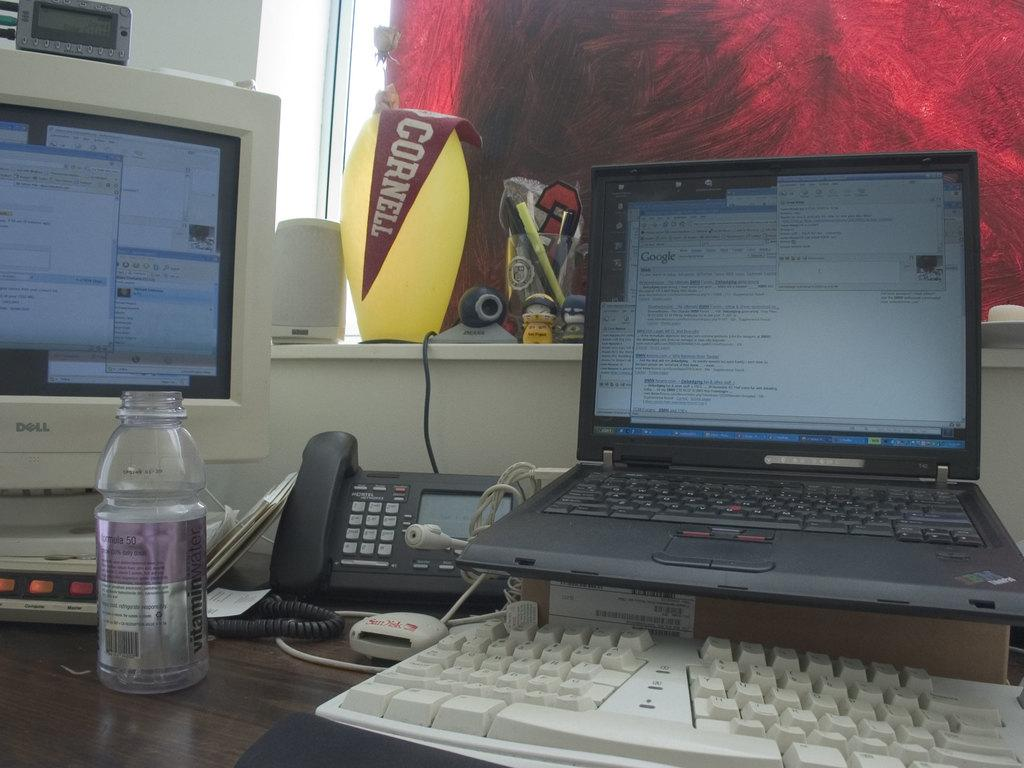<image>
Render a clear and concise summary of the photo. A desk with a computer has a banner that has Cornell on the window ledge. 